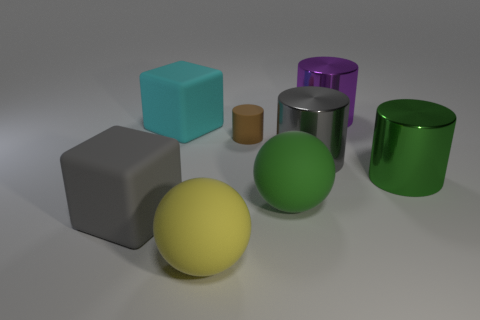Add 1 purple cylinders. How many objects exist? 9 Subtract all blocks. How many objects are left? 6 Subtract all large things. Subtract all brown objects. How many objects are left? 0 Add 2 tiny cylinders. How many tiny cylinders are left? 3 Add 2 green cylinders. How many green cylinders exist? 3 Subtract 0 cyan balls. How many objects are left? 8 